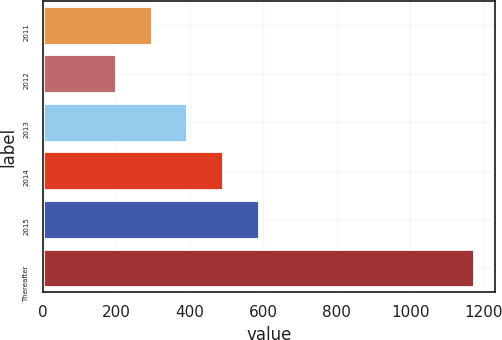Convert chart. <chart><loc_0><loc_0><loc_500><loc_500><bar_chart><fcel>2011<fcel>2012<fcel>2013<fcel>2014<fcel>2015<fcel>Thereafter<nl><fcel>296.4<fcel>199<fcel>393.8<fcel>491.2<fcel>588.6<fcel>1173<nl></chart> 